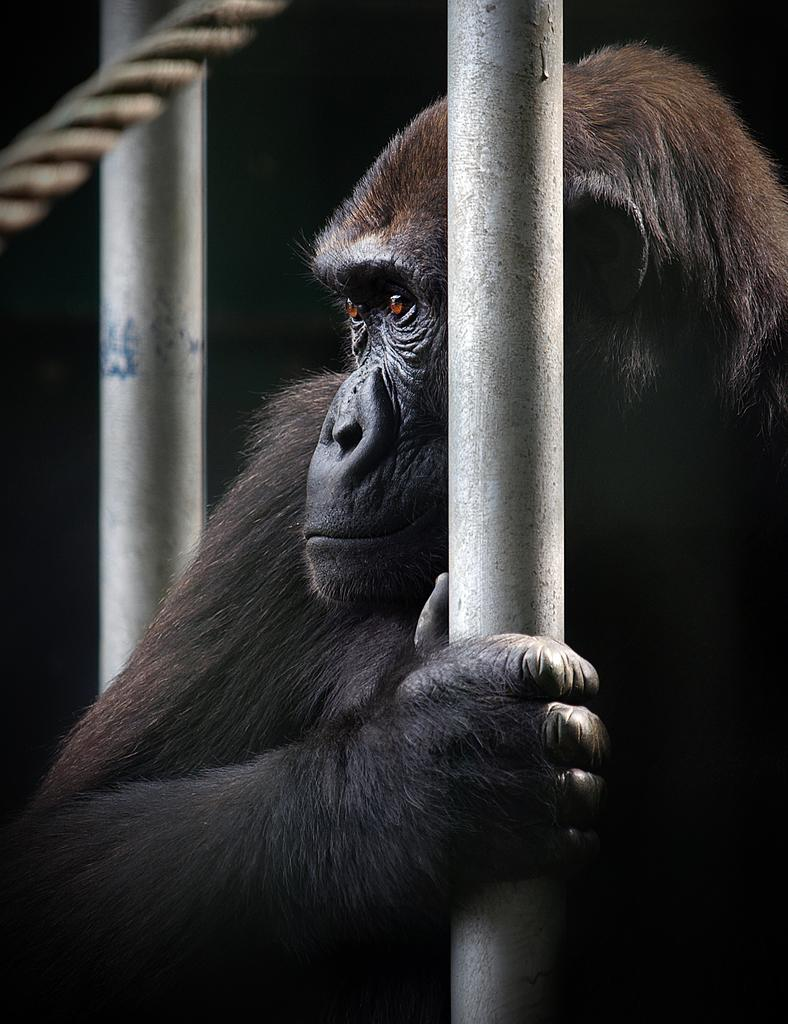What type of animal can be seen in the image? There is an animal in the image, but its specific type cannot be determined from the provided facts. What is the animal holding in the image? The animal is holding a pole in the image. Where is the pole located in the image? The pole is on the left side of the image. What is attached to the pole in the image? There is a rope on the left top of the image. What type of land can be seen in the background of the image? There is no information about the background or land in the image, so it cannot be determined. What is the animal doing downtown in the image? There is no mention of downtown or any urban setting in the image, so it cannot be determined. 